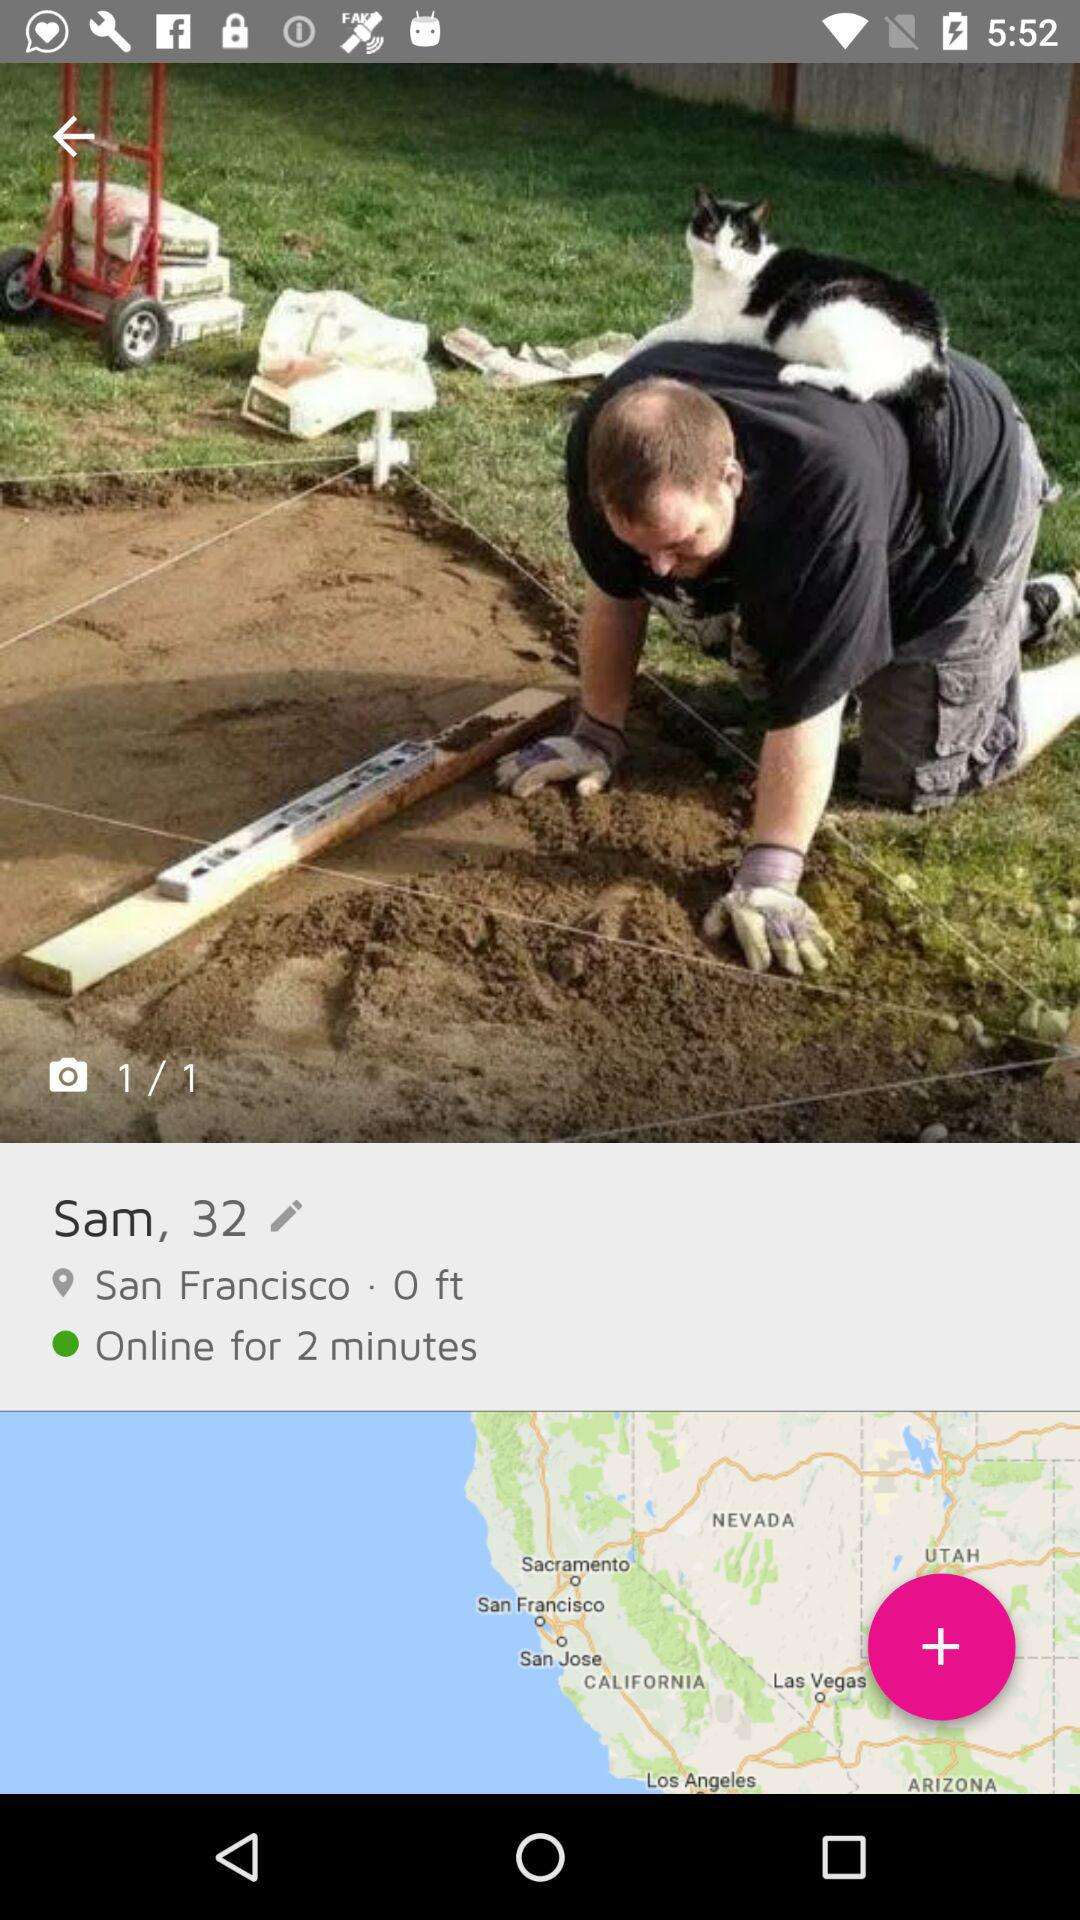How many more pictures are there than locations?
Answer the question using a single word or phrase. 1 